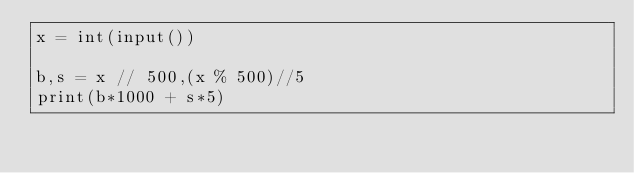Convert code to text. <code><loc_0><loc_0><loc_500><loc_500><_Python_>x = int(input())

b,s = x // 500,(x % 500)//5
print(b*1000 + s*5)</code> 